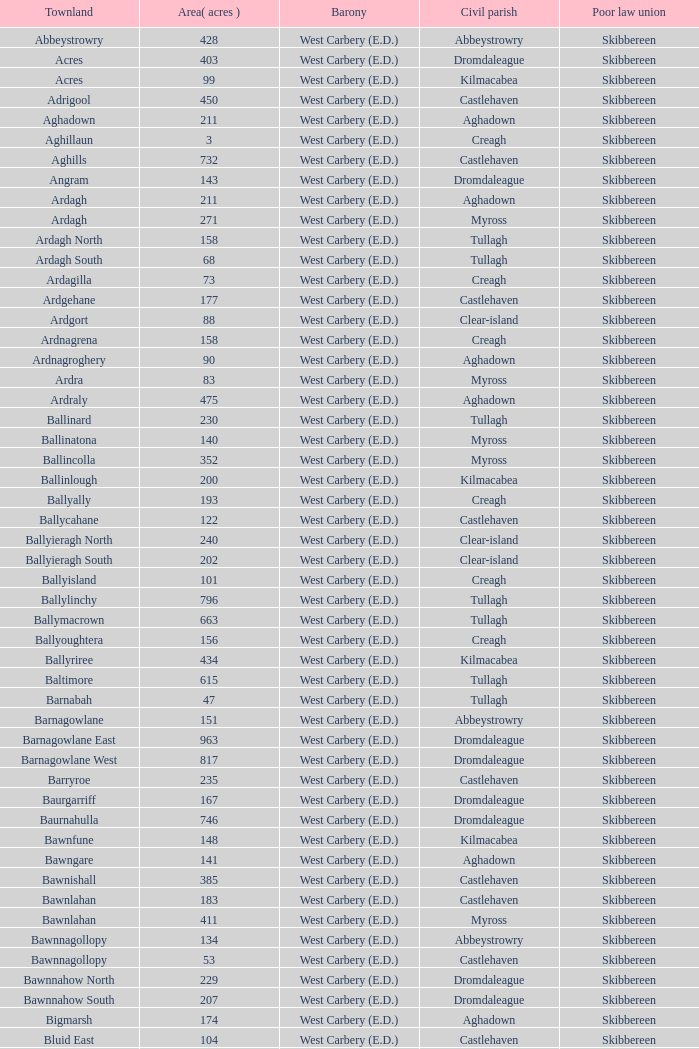What are the civil parishes of the Loughmarsh townland? Aghadown. 